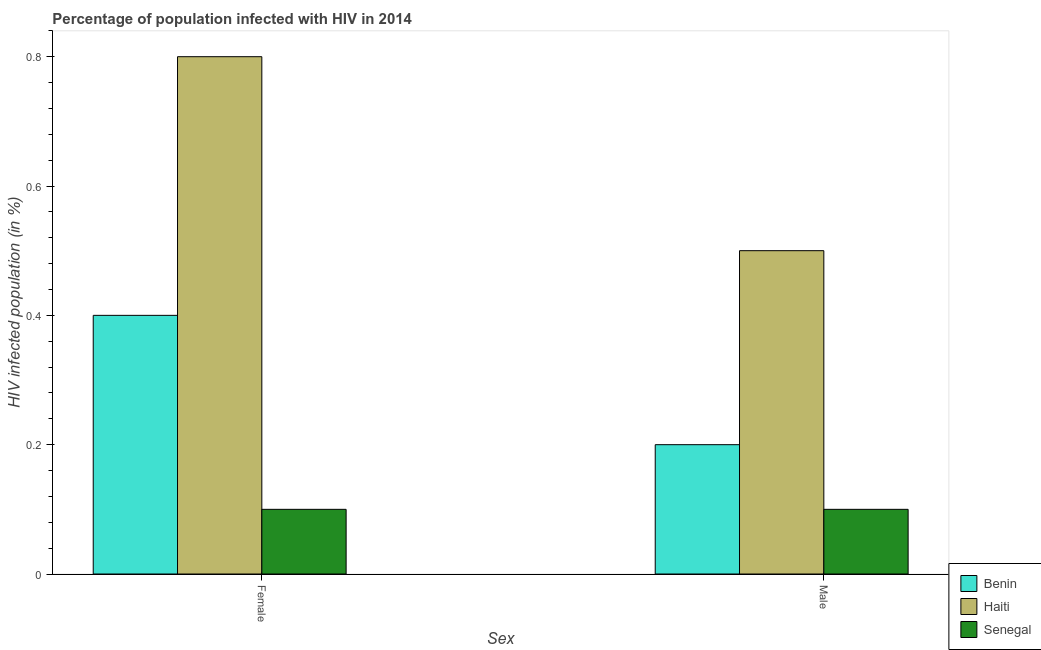How many different coloured bars are there?
Your answer should be compact. 3. How many groups of bars are there?
Give a very brief answer. 2. Are the number of bars per tick equal to the number of legend labels?
Make the answer very short. Yes. What is the label of the 1st group of bars from the left?
Offer a very short reply. Female. What is the percentage of females who are infected with hiv in Haiti?
Ensure brevity in your answer.  0.8. Across all countries, what is the maximum percentage of males who are infected with hiv?
Keep it short and to the point. 0.5. In which country was the percentage of females who are infected with hiv maximum?
Offer a terse response. Haiti. In which country was the percentage of males who are infected with hiv minimum?
Provide a succinct answer. Senegal. What is the total percentage of males who are infected with hiv in the graph?
Make the answer very short. 0.8. What is the difference between the percentage of females who are infected with hiv in Senegal and that in Benin?
Offer a terse response. -0.3. What is the difference between the percentage of females who are infected with hiv in Haiti and the percentage of males who are infected with hiv in Senegal?
Ensure brevity in your answer.  0.7. What is the average percentage of males who are infected with hiv per country?
Your answer should be compact. 0.27. What is the difference between the percentage of females who are infected with hiv and percentage of males who are infected with hiv in Haiti?
Your answer should be compact. 0.3. What is the ratio of the percentage of males who are infected with hiv in Benin to that in Haiti?
Provide a succinct answer. 0.4. In how many countries, is the percentage of females who are infected with hiv greater than the average percentage of females who are infected with hiv taken over all countries?
Provide a short and direct response. 1. What does the 2nd bar from the left in Male represents?
Make the answer very short. Haiti. What does the 1st bar from the right in Male represents?
Provide a short and direct response. Senegal. How many bars are there?
Offer a terse response. 6. What is the difference between two consecutive major ticks on the Y-axis?
Provide a short and direct response. 0.2. Does the graph contain grids?
Make the answer very short. No. How many legend labels are there?
Give a very brief answer. 3. How are the legend labels stacked?
Ensure brevity in your answer.  Vertical. What is the title of the graph?
Provide a short and direct response. Percentage of population infected with HIV in 2014. What is the label or title of the X-axis?
Your response must be concise. Sex. What is the label or title of the Y-axis?
Provide a short and direct response. HIV infected population (in %). What is the HIV infected population (in %) in Benin in Female?
Provide a short and direct response. 0.4. What is the HIV infected population (in %) in Haiti in Female?
Offer a terse response. 0.8. What is the HIV infected population (in %) in Senegal in Female?
Make the answer very short. 0.1. What is the HIV infected population (in %) in Haiti in Male?
Offer a very short reply. 0.5. What is the HIV infected population (in %) in Senegal in Male?
Offer a terse response. 0.1. Across all Sex, what is the maximum HIV infected population (in %) in Haiti?
Your answer should be compact. 0.8. Across all Sex, what is the maximum HIV infected population (in %) in Senegal?
Your response must be concise. 0.1. Across all Sex, what is the minimum HIV infected population (in %) of Senegal?
Your answer should be compact. 0.1. What is the total HIV infected population (in %) in Haiti in the graph?
Your answer should be very brief. 1.3. What is the difference between the HIV infected population (in %) in Benin in Female and that in Male?
Offer a terse response. 0.2. What is the difference between the HIV infected population (in %) in Haiti in Female and that in Male?
Your answer should be very brief. 0.3. What is the average HIV infected population (in %) in Benin per Sex?
Your answer should be compact. 0.3. What is the average HIV infected population (in %) of Haiti per Sex?
Your answer should be very brief. 0.65. What is the average HIV infected population (in %) in Senegal per Sex?
Provide a succinct answer. 0.1. What is the difference between the HIV infected population (in %) of Benin and HIV infected population (in %) of Haiti in Female?
Give a very brief answer. -0.4. What is the difference between the HIV infected population (in %) in Haiti and HIV infected population (in %) in Senegal in Female?
Make the answer very short. 0.7. What is the difference between the HIV infected population (in %) in Benin and HIV infected population (in %) in Haiti in Male?
Your response must be concise. -0.3. What is the difference between the HIV infected population (in %) in Benin and HIV infected population (in %) in Senegal in Male?
Keep it short and to the point. 0.1. What is the difference between the HIV infected population (in %) in Haiti and HIV infected population (in %) in Senegal in Male?
Your answer should be compact. 0.4. What is the difference between the highest and the second highest HIV infected population (in %) in Senegal?
Ensure brevity in your answer.  0. What is the difference between the highest and the lowest HIV infected population (in %) in Benin?
Provide a succinct answer. 0.2. What is the difference between the highest and the lowest HIV infected population (in %) in Haiti?
Your response must be concise. 0.3. 